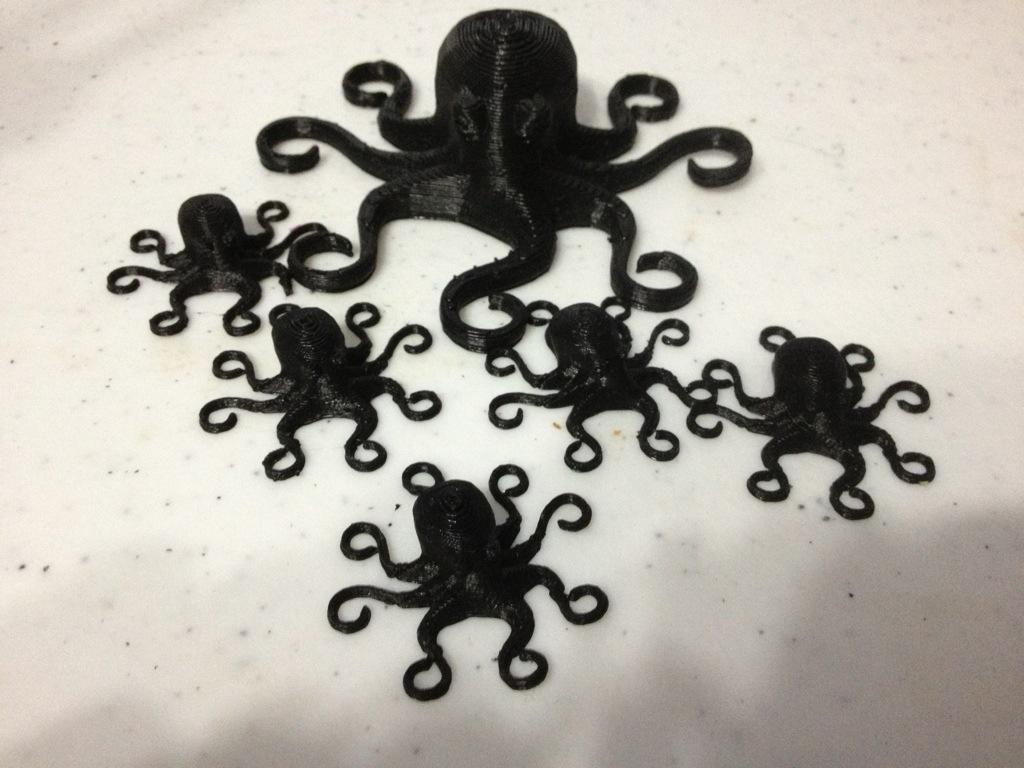Could you give a brief overview of what you see in this image? In this image there is a white thing. It might be a cake. In the middle of the image there are a few octopuses made with cream. Those are black in color. 